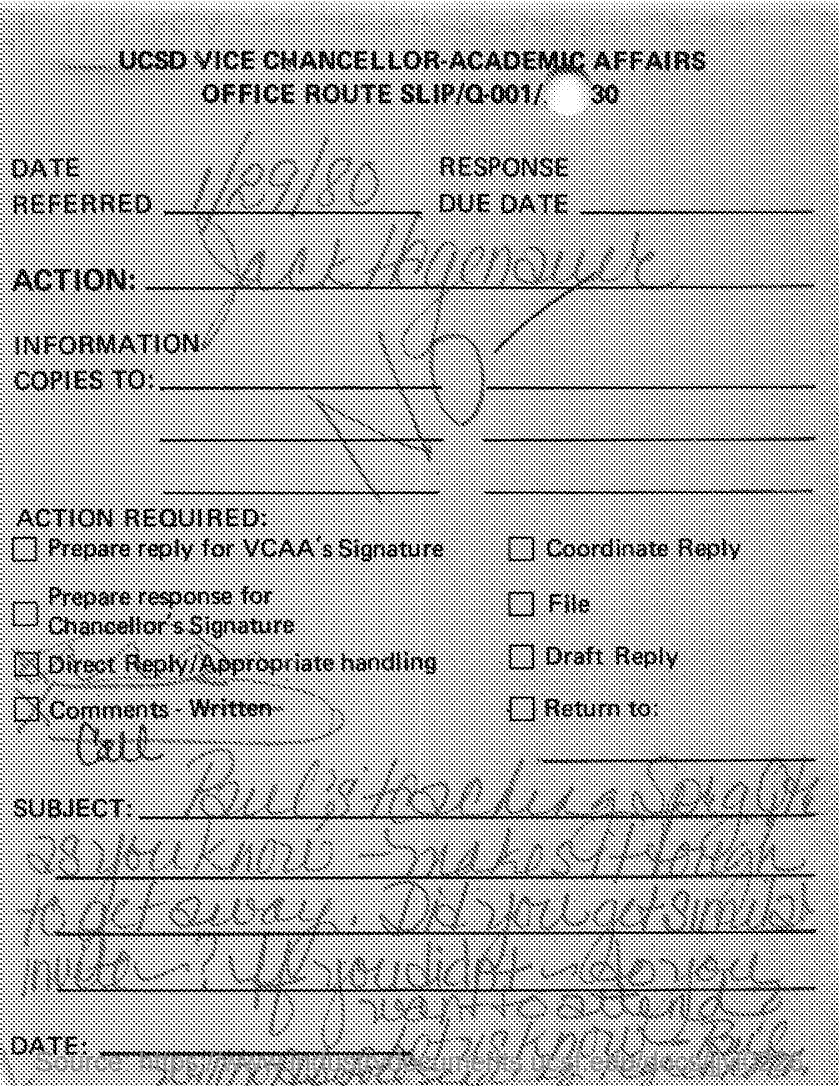Draw attention to some important aspects in this diagram. The date referred to in the slip is January 29, 1980. 